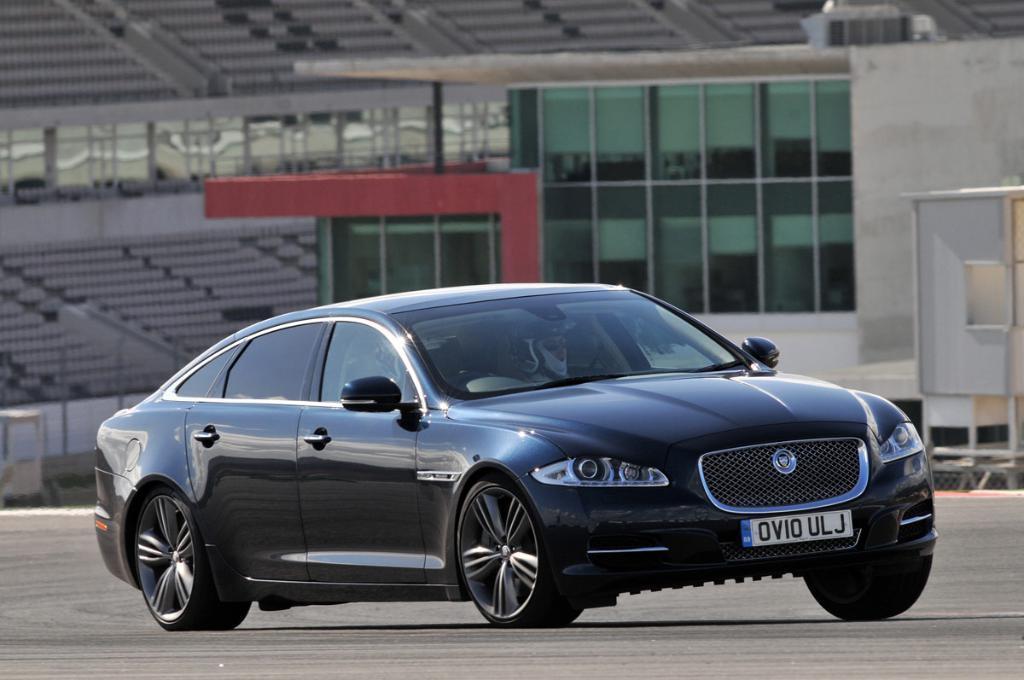Describe this image in one or two sentences. Here we can see two persons riding in a car on the road. In the background there is a building,chairs,poles,glasses and some other objects. 